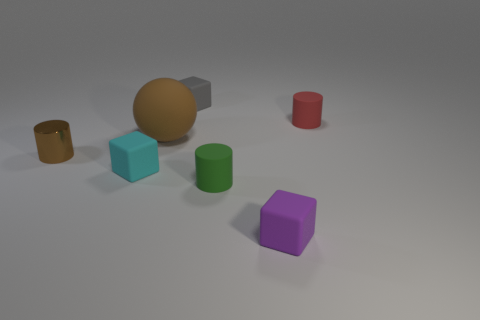How many objects are there in total in the image? There are a total of six objects in the image, including cylinders, cubes, and what appears to be a sphere. 